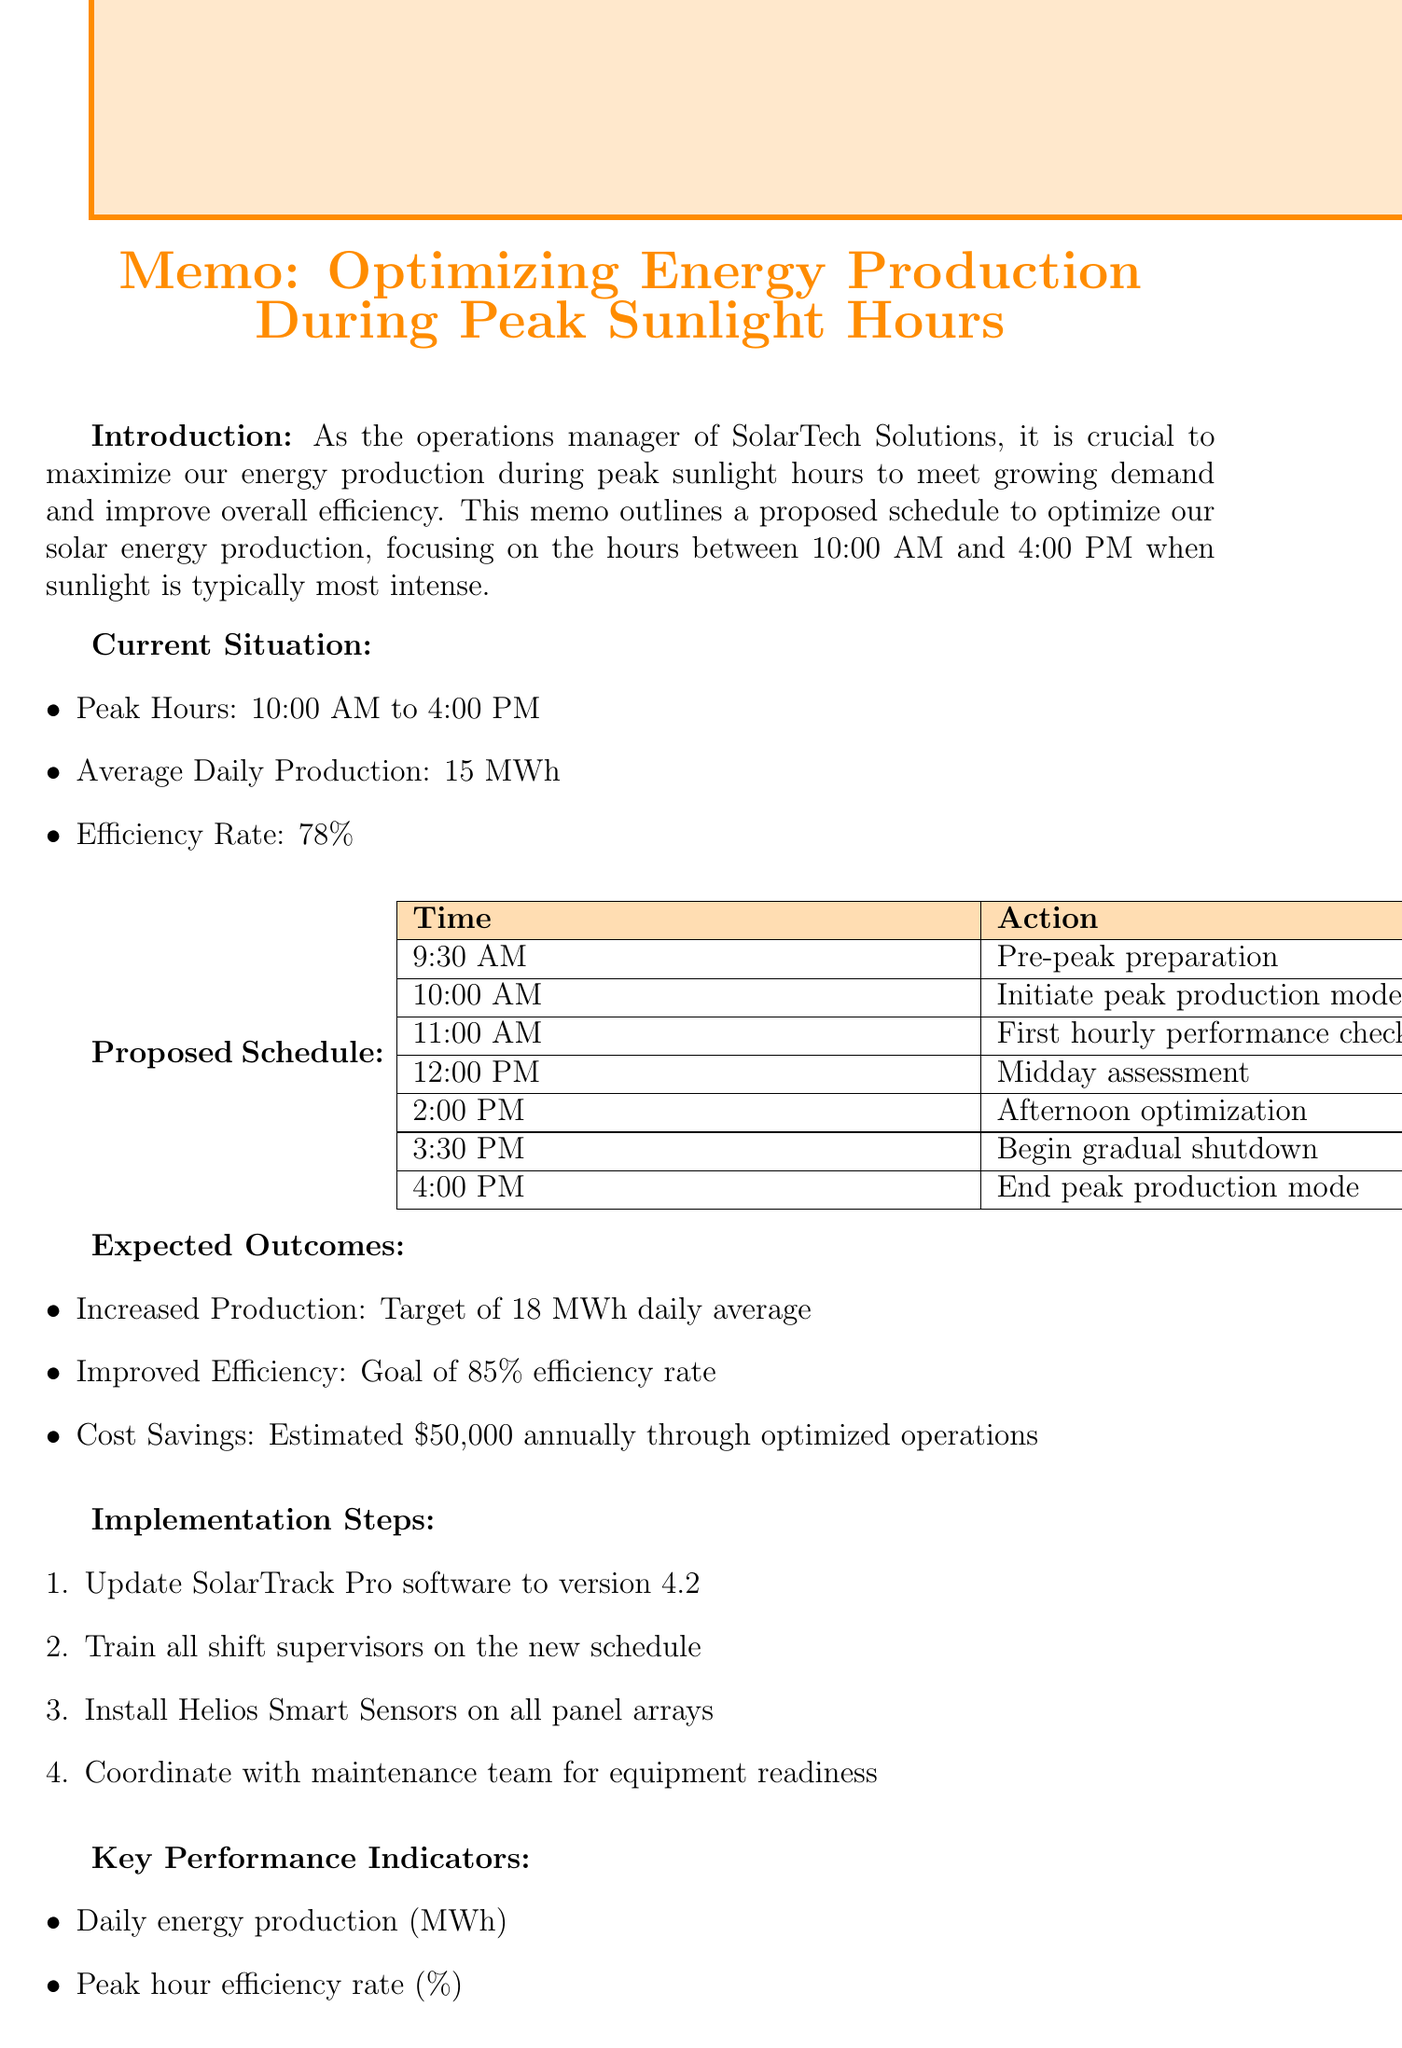What is the peak production mode initiation time? The time to initiate peak production mode is specified in the proposed schedule.
Answer: 10:00 AM What is the expected increase in daily average production? The document specifies the target for daily average production after optimization.
Answer: 18 MWh What is the current efficiency rate? The current efficiency rate is outlined in the current situation section.
Answer: 78% What action is taken at 2:00 PM? The proposed schedule includes actions for each hour, specifying what is to be done at 2:00 PM.
Answer: Afternoon optimization When is the feedback due for this proposal? The conclusion section includes the deadline for feedback on the proposal.
Answer: Friday, May 15th What is the goal for the efficiency rate after optimization? The expected outcomes include the goal for improved efficiency.
Answer: 85% What is the estimated annual cost savings from optimized operations? The expected outcomes highlight the cost savings from the proposed changes.
Answer: $50,000 How many implementation steps are listed? The implementation steps are detailed in the respective section, indicating how many there are.
Answer: Four 